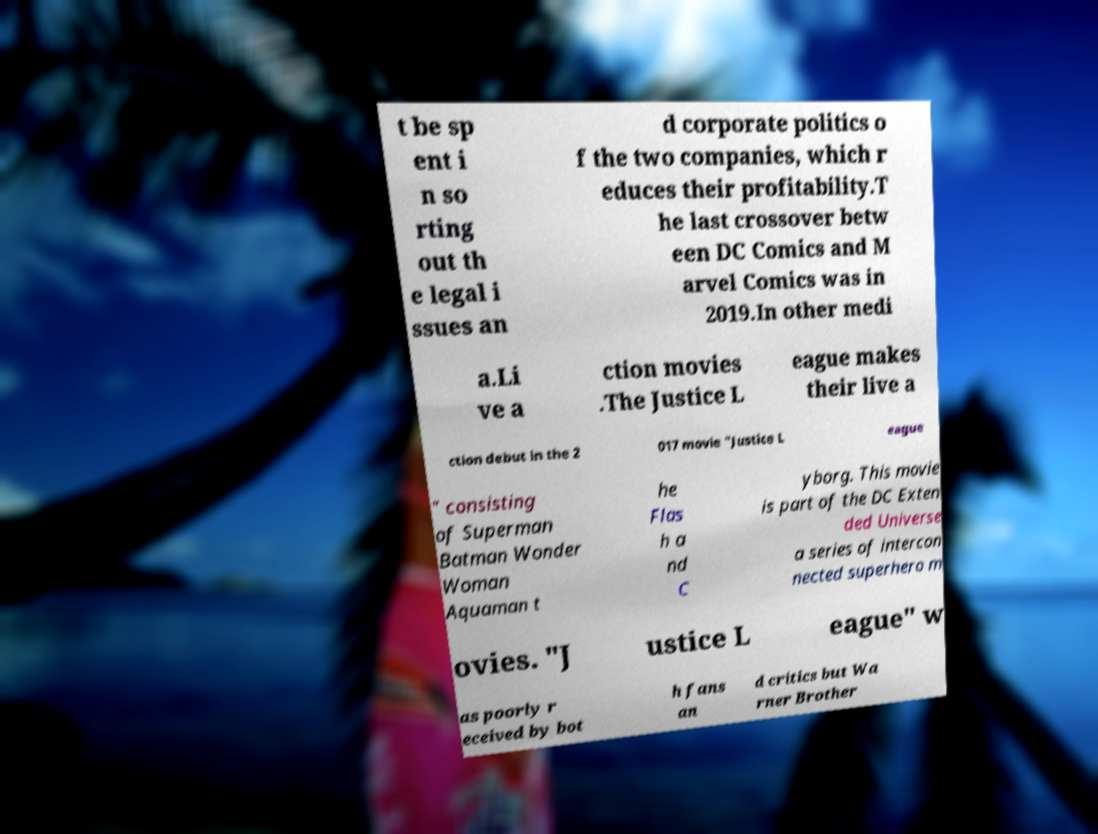Could you extract and type out the text from this image? t be sp ent i n so rting out th e legal i ssues an d corporate politics o f the two companies, which r educes their profitability.T he last crossover betw een DC Comics and M arvel Comics was in 2019.In other medi a.Li ve a ction movies .The Justice L eague makes their live a ction debut in the 2 017 movie "Justice L eague " consisting of Superman Batman Wonder Woman Aquaman t he Flas h a nd C yborg. This movie is part of the DC Exten ded Universe a series of intercon nected superhero m ovies. "J ustice L eague" w as poorly r eceived by bot h fans an d critics but Wa rner Brother 